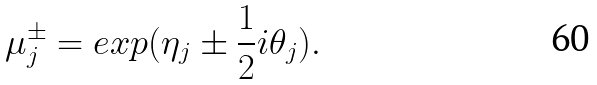Convert formula to latex. <formula><loc_0><loc_0><loc_500><loc_500>\mu _ { j } ^ { \pm } = e x p ( \eta _ { j } \pm \frac { 1 } { 2 } i \theta _ { j } ) .</formula> 